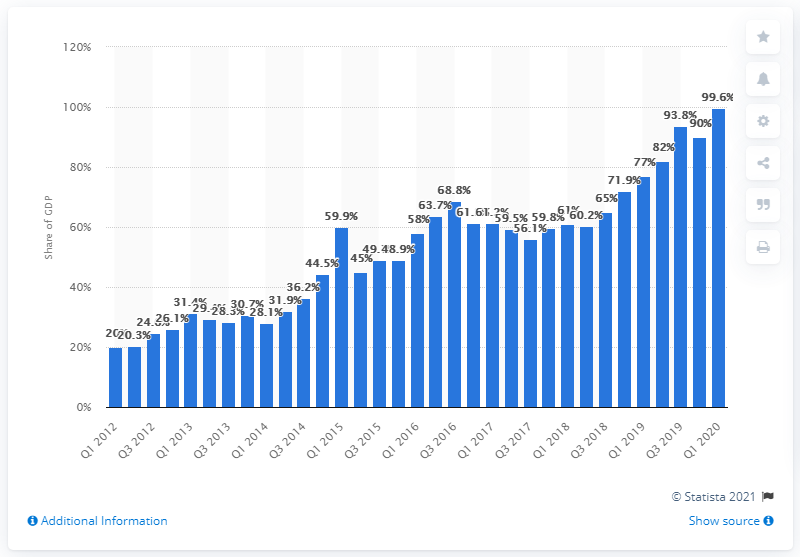Point out several critical features in this image. The Netherlands' NIIP value in the first quarter of 2020 was 99.6. The lower limit for the NIIP is 99.6%. 